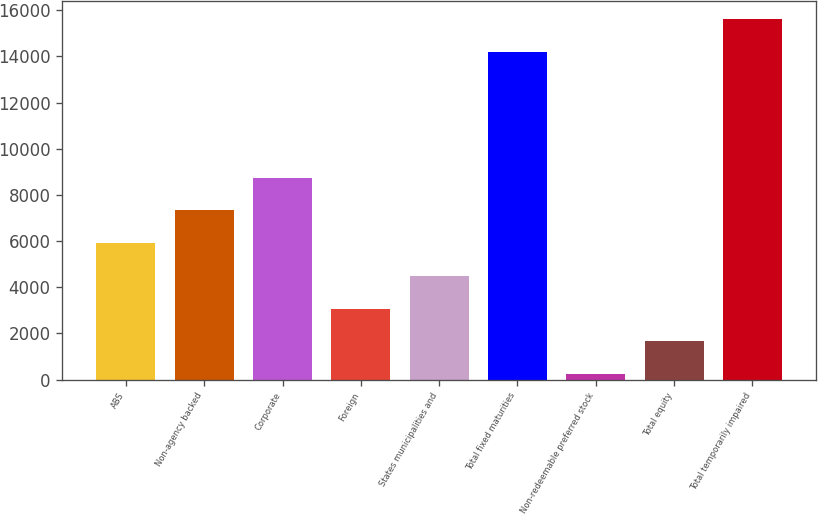Convert chart to OTSL. <chart><loc_0><loc_0><loc_500><loc_500><bar_chart><fcel>ABS<fcel>Non-agency backed<fcel>Corporate<fcel>Foreign<fcel>States municipalities and<fcel>Total fixed maturities<fcel>Non-redeemable preferred stock<fcel>Total equity<fcel>Total temporarily impaired<nl><fcel>5913.8<fcel>7333<fcel>8752.2<fcel>3075.4<fcel>4494.6<fcel>14189<fcel>237<fcel>1656.2<fcel>15608.2<nl></chart> 